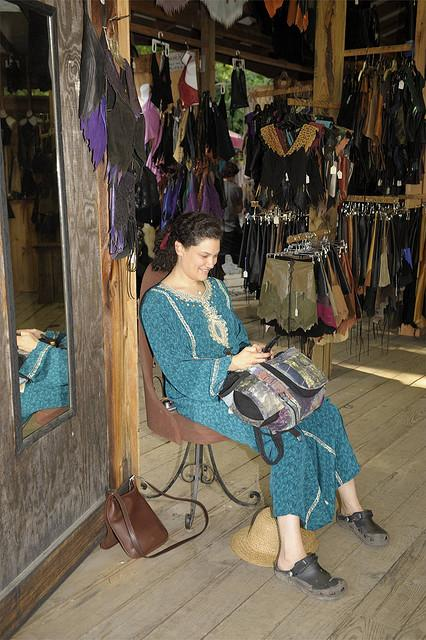What's the lady doing? Please explain your reasoning. texting. Given she's on her phone, this is the most likely answer. 